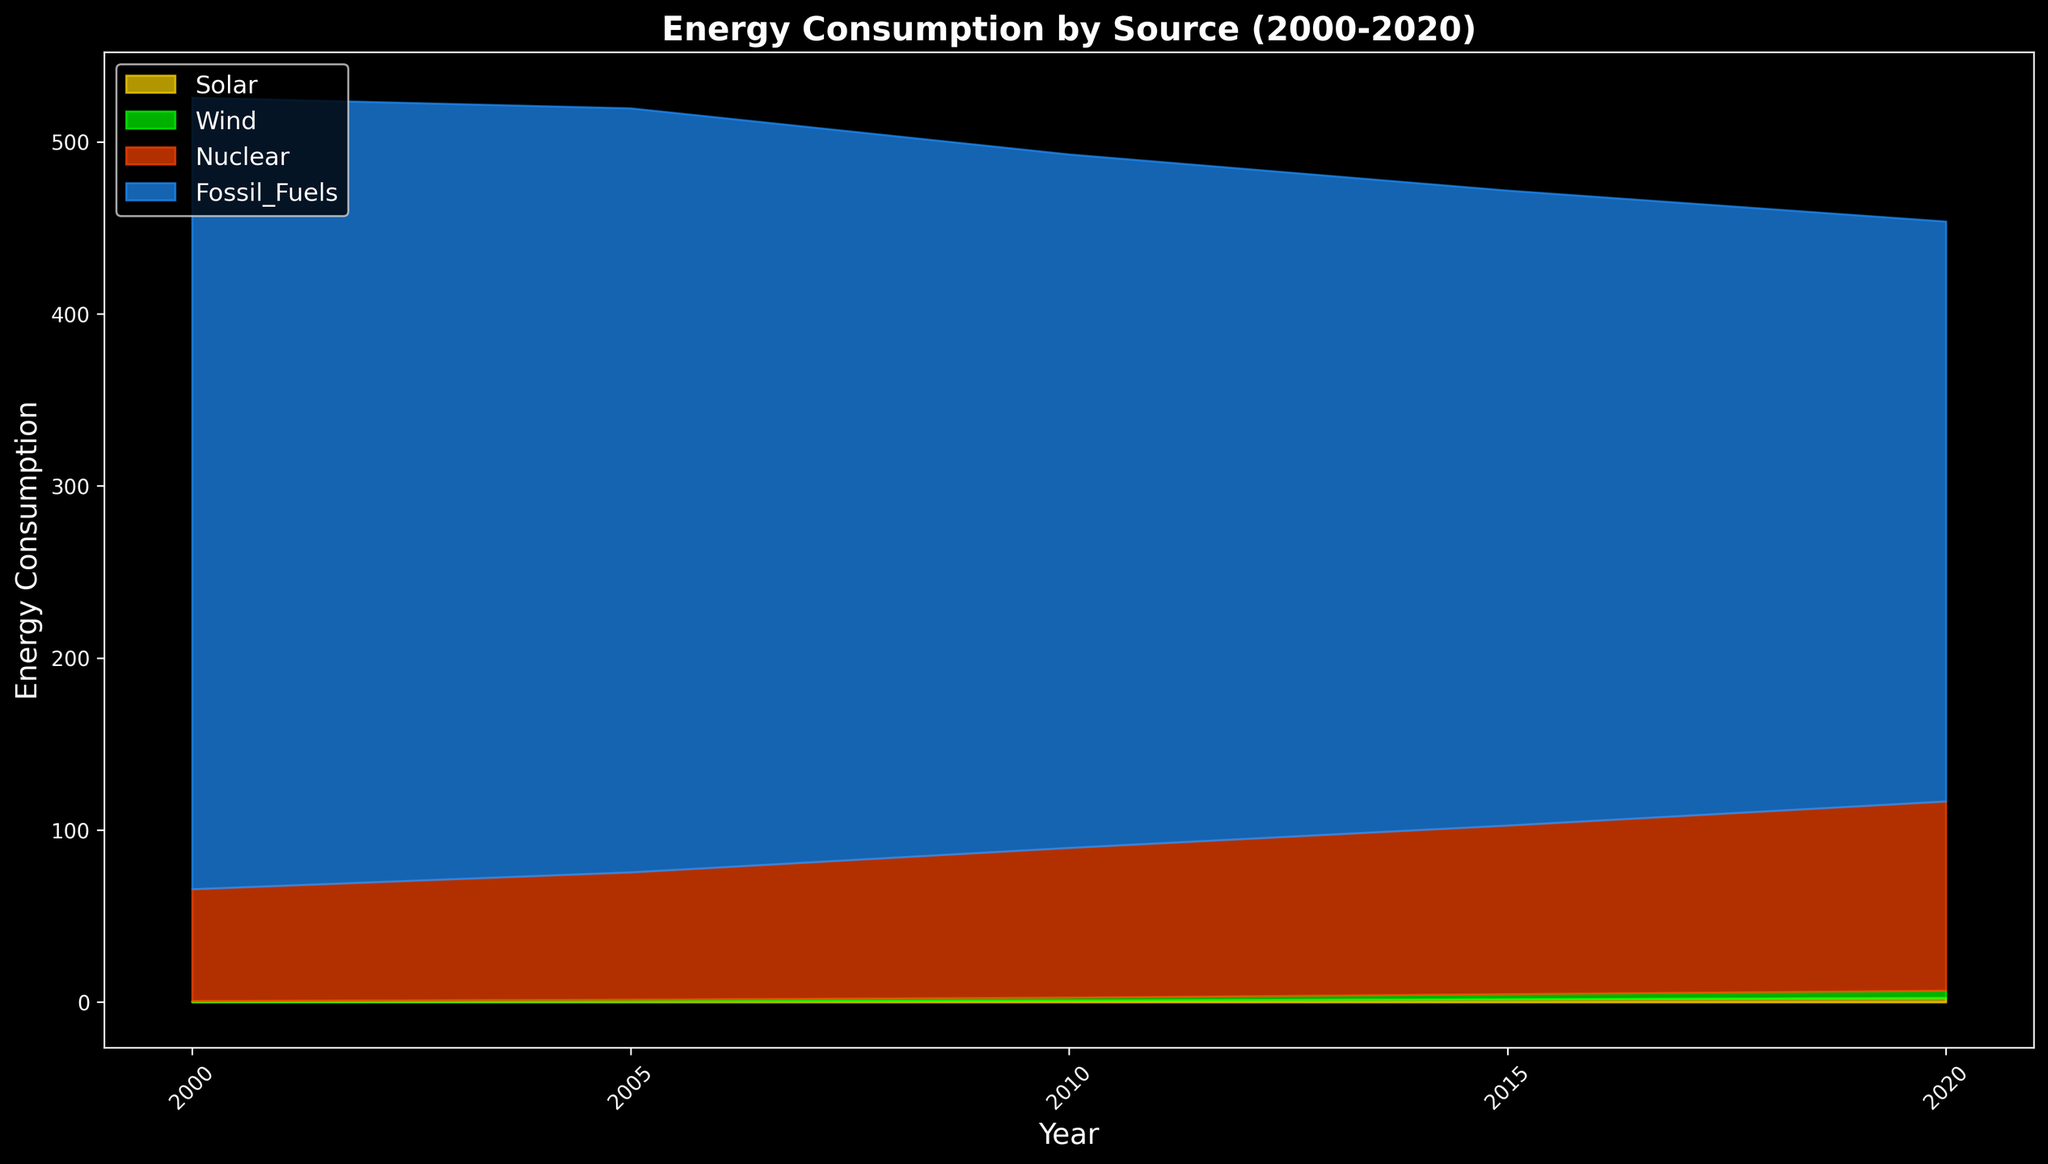What is the trend in solar energy consumption from 2000 to 2020? By observing the yellow area representing solar energy consumption, it can be seen that the area increases over time from 2000 to 2020, indicating an overall upward trend in solar energy consumption.
Answer: Upward trend Which energy source had the highest consumption in 2020? In 2020, the blue area representing fossil fuels is the largest among all energy sources, indicating that fossil fuels had the highest consumption.
Answer: Fossil fuels How does wind energy consumption in North America in 2020 compare to 2000? By comparing the size of the green area in North America for the years 2000 and 2020, we can see that the green area in 2020 is much larger, indicating a significant increase in wind energy consumption.
Answer: Increased By how much did nuclear energy consumption in Europe increase between 2000 and 2020? In 2000, nuclear energy consumption in Europe (orange area) starts at approximately 25 units, and in 2020 it is about 35 units. The increase can be calculated as 35 - 25 = 10 units.
Answer: 10 units Which region had the most significant increase in solar energy consumption between 2000 and 2020? By looking at the growth of the yellow area for each region, Oceania shows the most significant increase from almost 0 in 2000 to a substantial size in 2020.
Answer: Oceania Is there any energy source that decreased in consumption across all regions from 2000 to 2020? By analyzing the four areas (solar, wind, nuclear, fossil fuels) for changes in size, fossil fuels (blue) are observed to consistently decrease in size from 2000 to 2020 across all regions.
Answer: Fossil fuels What is the combined energy consumption of renewable sources (solar and wind) in Asia in 2020? In Asia, the heights of the yellow (solar) and green (wind) areas for 2020 are approximately 0.4 and 0.7, respectively. Combining these gives 0.4 + 0.7 = 1.1 units.
Answer: 1.1 units How did the ratio of nuclear to fossil fuel energy consumption change in North America from 2000 to 2020? In 2000, North America's nuclear consumption (orange) is 20 units and fossil fuel consumption (blue) is 70 units, making the ratio 20/70. In 2020, nuclear is 30 units and fossil fuels 50 units (30/50). Calculating the change: (20/70) compared to (30/50). 0.2857 to 0.6.
Answer: Increased Which energy source had the least growth in Africa from 2000 to 2020? Observing the areas for Africa, the nuclear energy consumption (orange) shows the smallest change in size, indicating the least growth.
Answer: Nuclear How does the growth in wind energy consumption in Europe compare to North America from 2000 to 2020? Looking at the green areas for both regions, the increase in Europe is from 0.15 units in 2000 to 0.9 units in 2020, while in North America it is from 0.1 units to 0.8 units. This suggests a greater absolute growth in Europe by comparison (0.75 units in Europe vs. 0.7 units in North America).
Answer: Greater growth in Europe 